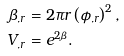<formula> <loc_0><loc_0><loc_500><loc_500>\beta _ { , r } & = 2 \pi r \left ( \phi _ { , r } \right ) ^ { 2 } , \\ V _ { , r } & = e ^ { 2 \beta } .</formula> 